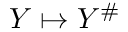Convert formula to latex. <formula><loc_0><loc_0><loc_500><loc_500>Y \mapsto Y ^ { \# }</formula> 